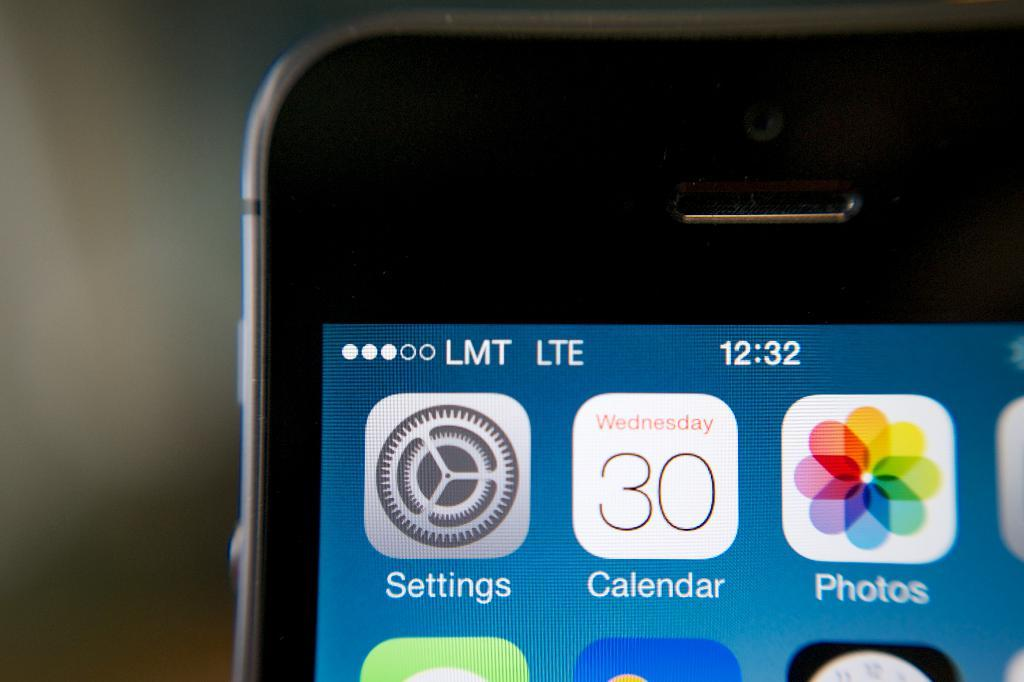<image>
Share a concise interpretation of the image provided. A smartphone on the LMT network showing 3 of 5 marks of signal strength. 